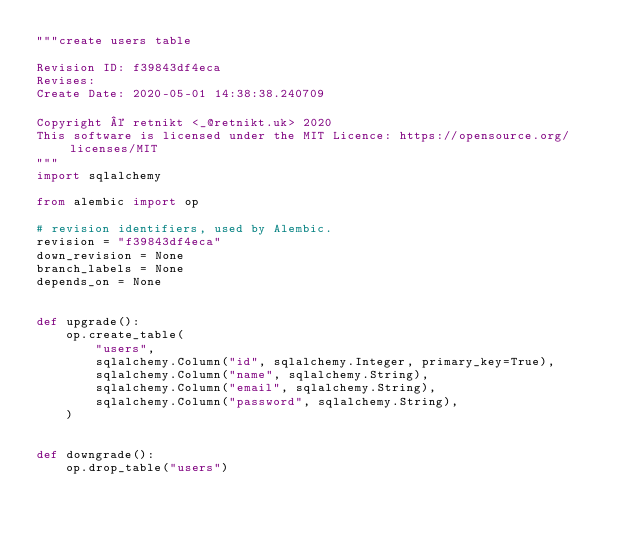Convert code to text. <code><loc_0><loc_0><loc_500><loc_500><_Python_>"""create users table

Revision ID: f39843df4eca
Revises:
Create Date: 2020-05-01 14:38:38.240709

Copyright © retnikt <_@retnikt.uk> 2020
This software is licensed under the MIT Licence: https://opensource.org/licenses/MIT
"""
import sqlalchemy

from alembic import op

# revision identifiers, used by Alembic.
revision = "f39843df4eca"
down_revision = None
branch_labels = None
depends_on = None


def upgrade():
    op.create_table(
        "users",
        sqlalchemy.Column("id", sqlalchemy.Integer, primary_key=True),
        sqlalchemy.Column("name", sqlalchemy.String),
        sqlalchemy.Column("email", sqlalchemy.String),
        sqlalchemy.Column("password", sqlalchemy.String),
    )


def downgrade():
    op.drop_table("users")
</code> 